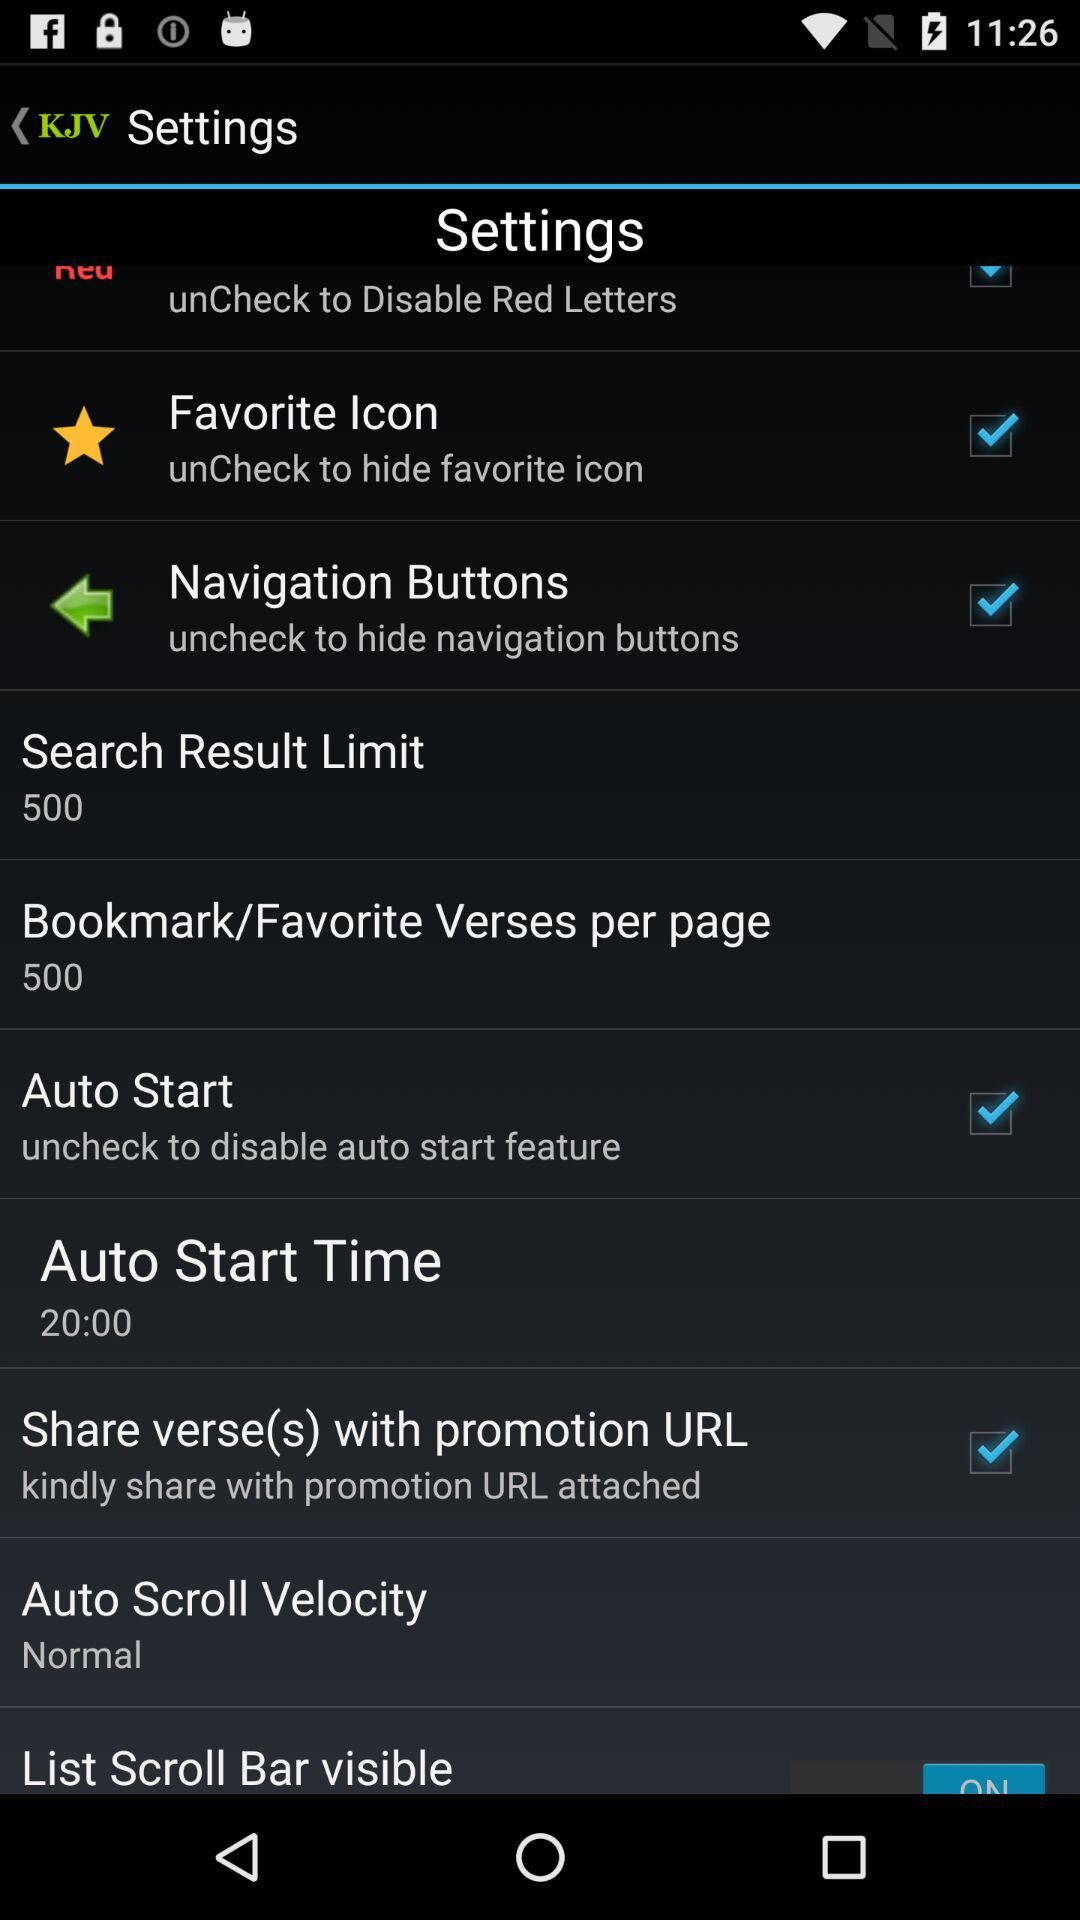What is the auto start time? The auto start time is 20:00. 